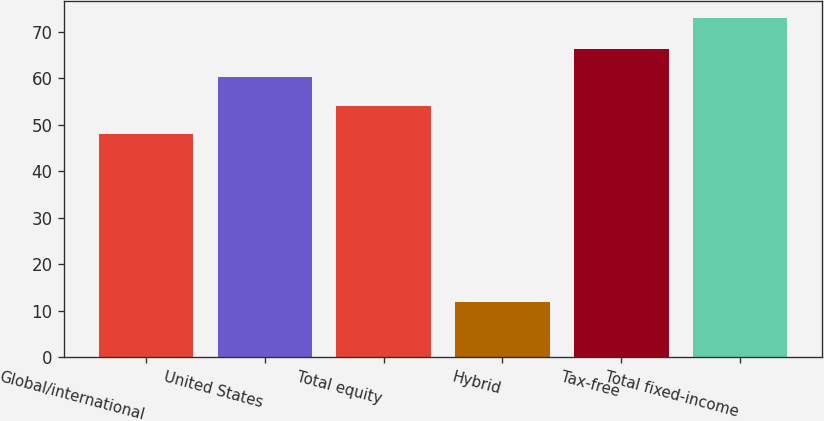Convert chart to OTSL. <chart><loc_0><loc_0><loc_500><loc_500><bar_chart><fcel>Global/international<fcel>United States<fcel>Total equity<fcel>Hybrid<fcel>Tax-free<fcel>Total fixed-income<nl><fcel>48<fcel>60.2<fcel>54.1<fcel>12<fcel>66.3<fcel>73<nl></chart> 